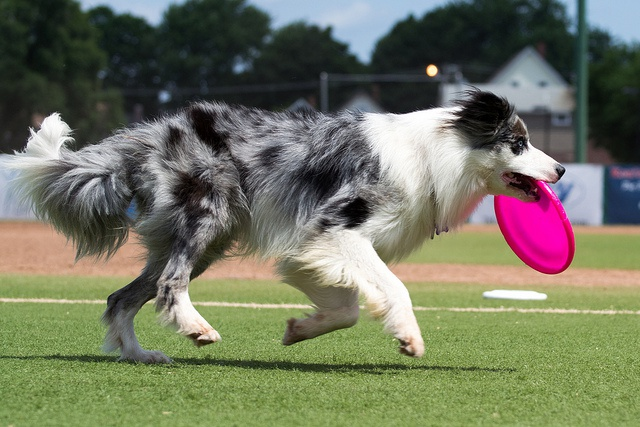Describe the objects in this image and their specific colors. I can see dog in black, gray, darkgray, and lightgray tones and frisbee in black, magenta, and brown tones in this image. 